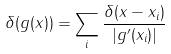Convert formula to latex. <formula><loc_0><loc_0><loc_500><loc_500>\delta ( g ( x ) ) = \sum _ { i } { \frac { \delta ( x - x _ { i } ) } { | g ^ { \prime } ( x _ { i } ) | } }</formula> 